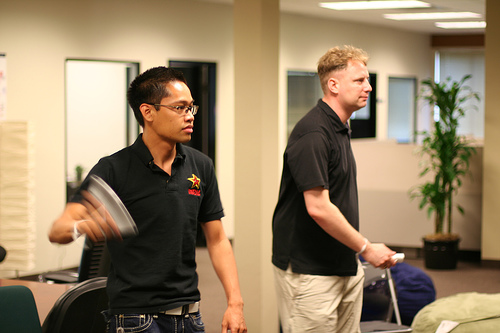Can you tell what time of day it might be based on the lighting in the image? The lighting inside the room is relatively bright, suggesting it could be daytime, complemented by artificial light to maintain visibility. 